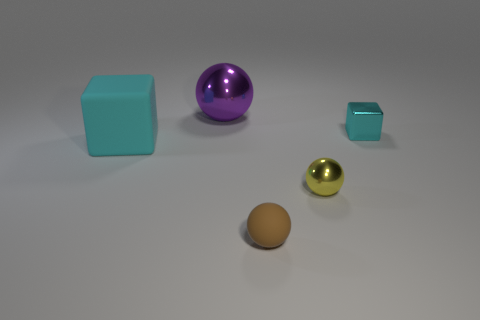What is the material of the cyan block on the right side of the sphere behind the shiny object that is to the right of the yellow ball?
Provide a succinct answer. Metal. Is there another cyan thing that has the same size as the cyan rubber object?
Your response must be concise. No. What is the size of the other object that is the same material as the small brown thing?
Your response must be concise. Large. There is a yellow shiny thing; what shape is it?
Provide a succinct answer. Sphere. Are the tiny cyan block and the ball that is on the left side of the brown rubber ball made of the same material?
Give a very brief answer. Yes. How many things are tiny yellow matte things or cyan cubes?
Make the answer very short. 2. Is there a small metallic ball?
Make the answer very short. Yes. What shape is the cyan object that is in front of the object that is right of the yellow metal thing?
Offer a very short reply. Cube. What number of things are either cyan objects on the left side of the yellow shiny object or cyan things that are on the left side of the tiny yellow shiny sphere?
Keep it short and to the point. 1. There is another object that is the same size as the purple object; what is its material?
Offer a terse response. Rubber. 